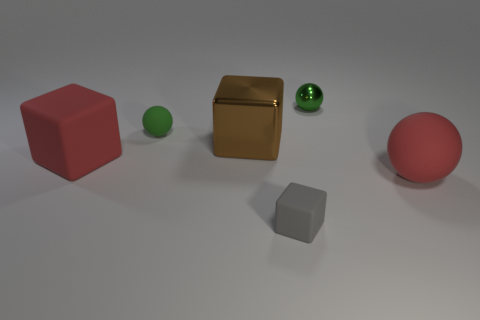Subtract all rubber balls. How many balls are left? 1 Add 2 large green blocks. How many objects exist? 8 Subtract 2 cubes. How many cubes are left? 1 Subtract all green spheres. How many spheres are left? 1 Subtract 0 gray cylinders. How many objects are left? 6 Subtract all green blocks. Subtract all red balls. How many blocks are left? 3 Subtract all green cylinders. How many red spheres are left? 1 Subtract all gray blocks. Subtract all green rubber things. How many objects are left? 4 Add 3 large shiny cubes. How many large shiny cubes are left? 4 Add 6 big brown metal cubes. How many big brown metal cubes exist? 7 